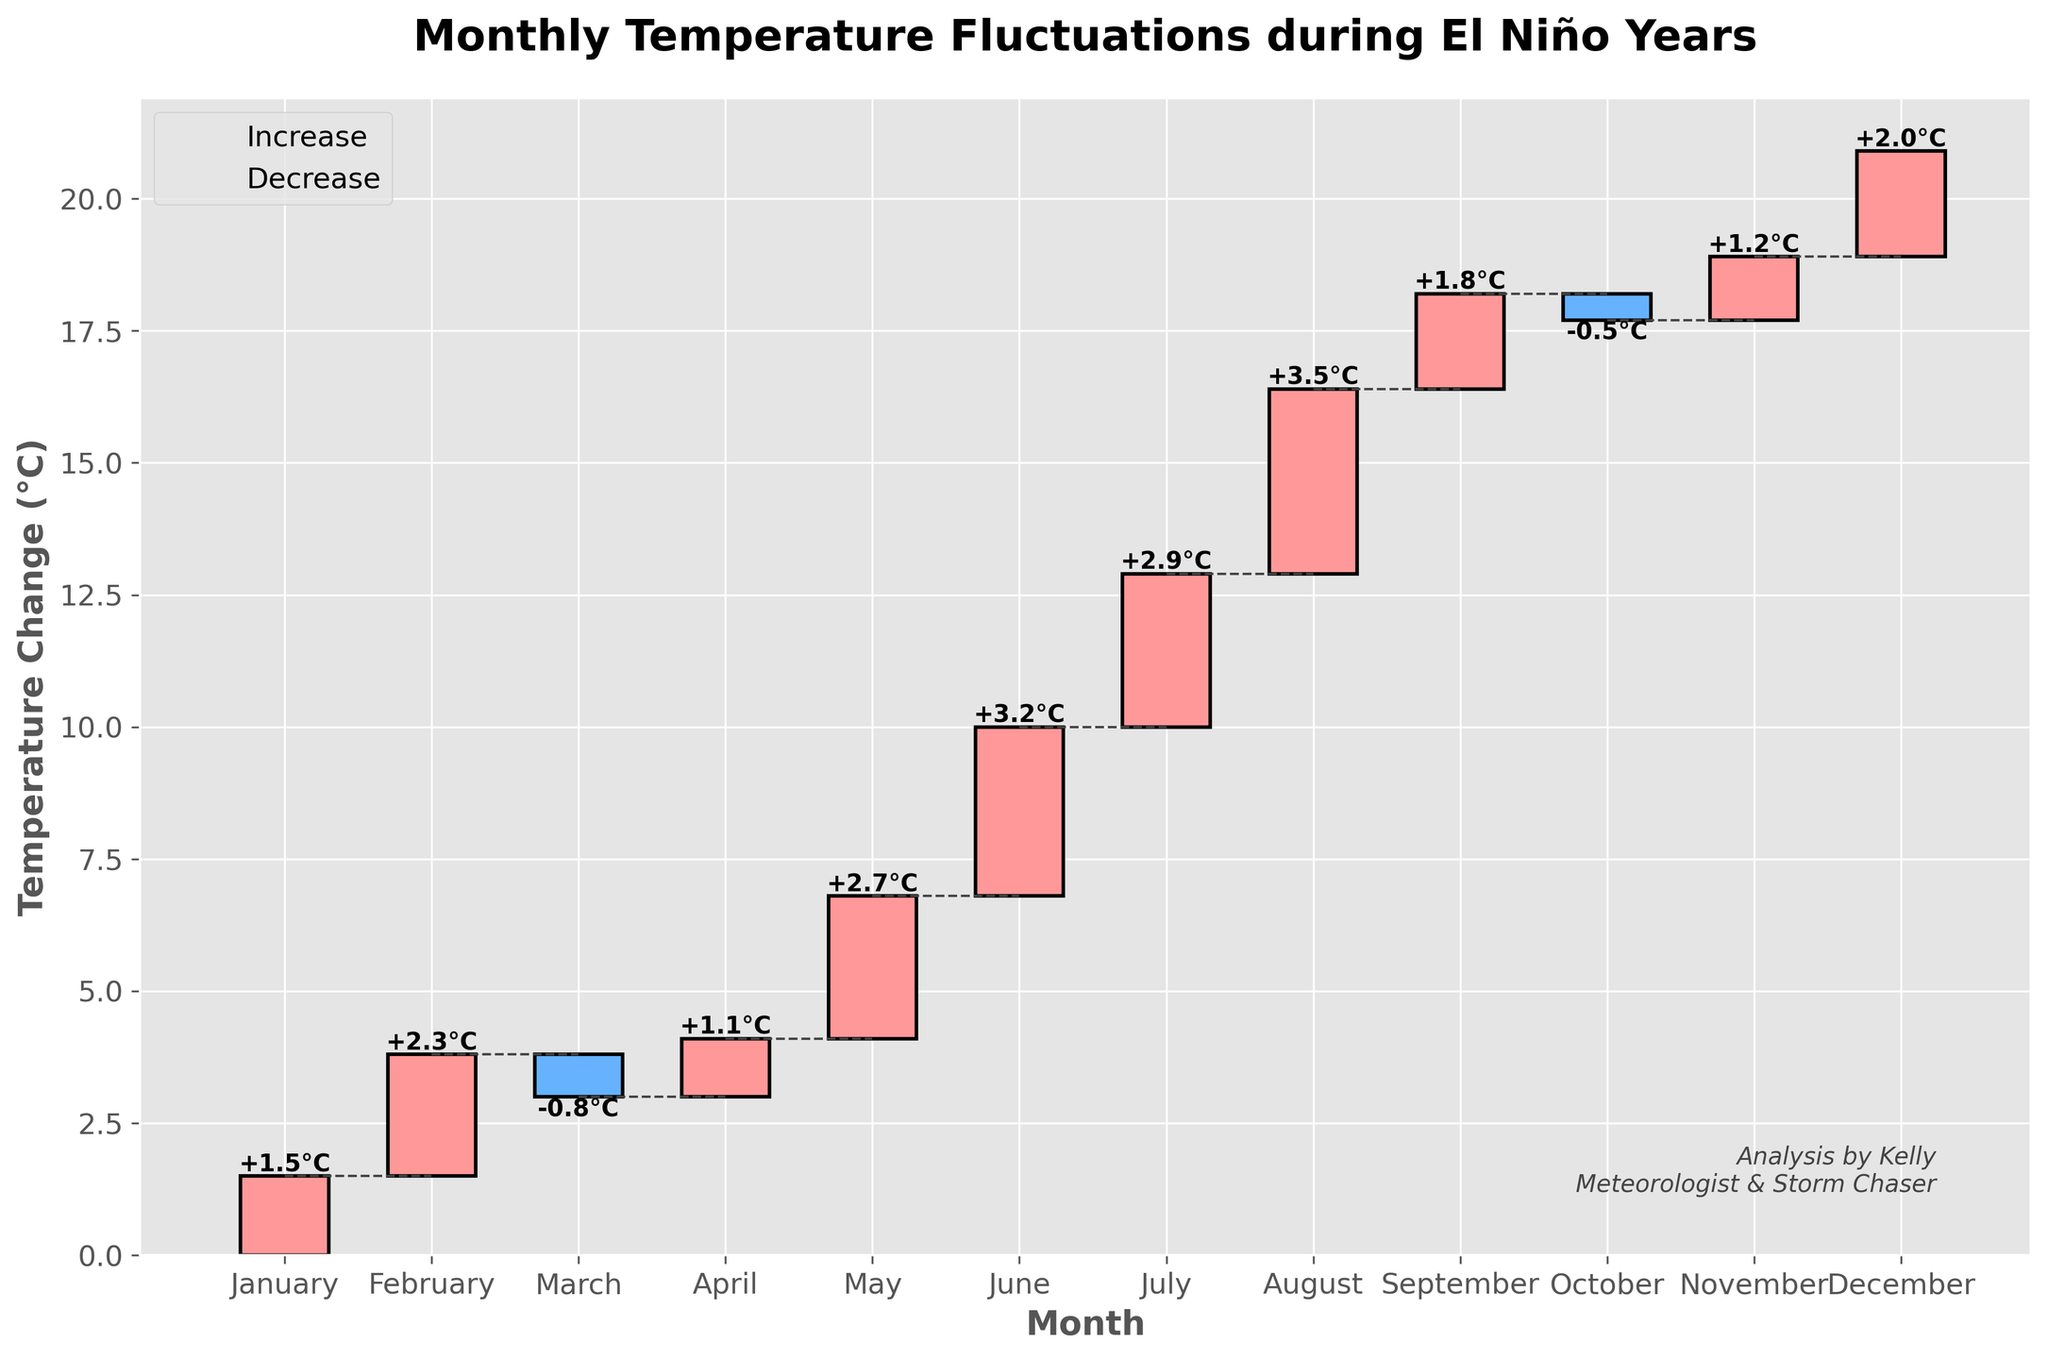What's the title of the chart? The title is presented at the top of the chart in large bold letters.
Answer: Monthly Temperature Fluctuations during El Niño Years Which months have a decrease in temperature? The color of the bars indicates whether the temperature has increased or decreased. Bars in blue represent a decrease in temperature.
Answer: March, October What is the temperature change for May? Each bar is labeled with the corresponding month's temperature change value.
Answer: +2.7°C What is the cumulative temperature change by the end of June? To find the cumulative change, add the temperature changes from January to June: 1.5 + 2.3 - 0.8 + 1.1 + 2.7 + 3.2.
Answer: +10.0°C Which month shows the highest temperature increase and by how much? By comparing the height and the labeled values of each bar, the month with the highest positive value can be identified.
Answer: August, +3.5°C What is the difference in temperature change between January and July? Subtract the temperature change in January from that in July: 2.9 - 1.5.
Answer: +1.4°C How many months have a temperature change greater than +2°C? Count the months where the labeled value exceeds +2°C.
Answer: 6 months (February, May, June, July, August, December) Which month presents the smallest absolute temperature change and what is its value? The smallest value can be found by looking at the bar heights and their labels, ignoring the sign.
Answer: March (-0.8°C) What is the overall cumulative temperature change by the end of December? Add up all the individual monthly changes: 1.5 + 2.3 - 0.8 + 1.1 + 2.7 + 3.2 + 2.9 + 3.5 + 1.8 - 0.5 + 1.2 + 2.0.
Answer: +21.9°C 